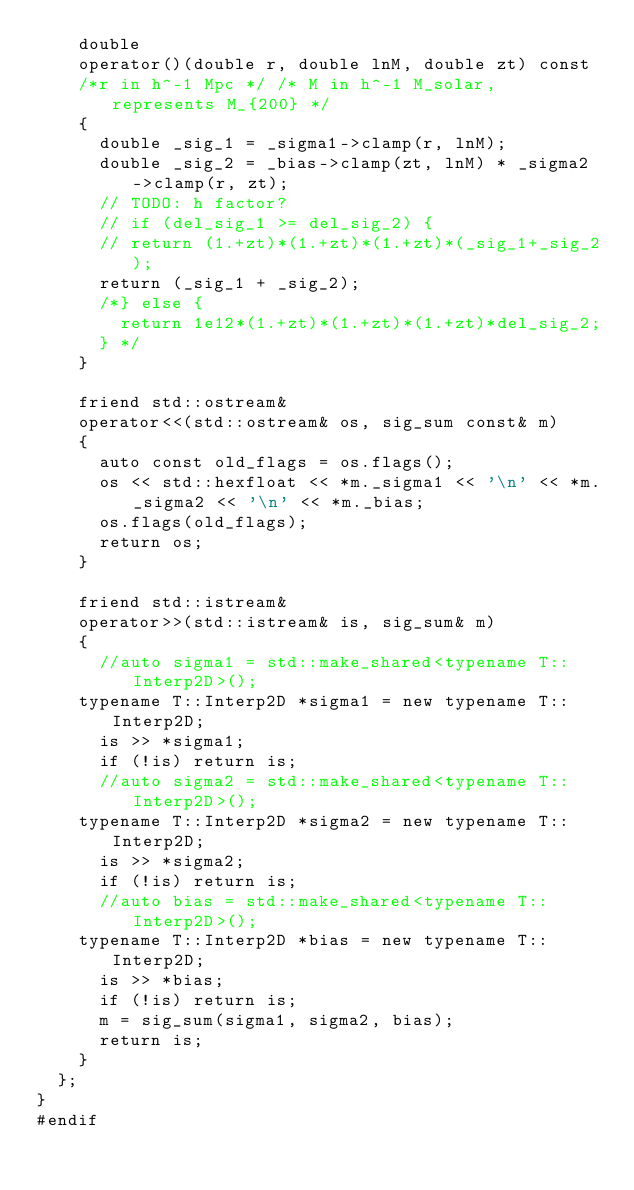Convert code to text. <code><loc_0><loc_0><loc_500><loc_500><_Cuda_>    double
    operator()(double r, double lnM, double zt) const
    /*r in h^-1 Mpc */ /* M in h^-1 M_solar, represents M_{200} */
    {
      double _sig_1 = _sigma1->clamp(r, lnM);
      double _sig_2 = _bias->clamp(zt, lnM) * _sigma2->clamp(r, zt);
      // TODO: h factor?
      // if (del_sig_1 >= del_sig_2) {
      // return (1.+zt)*(1.+zt)*(1.+zt)*(_sig_1+_sig_2);
      return (_sig_1 + _sig_2);
      /*} else {
        return 1e12*(1.+zt)*(1.+zt)*(1.+zt)*del_sig_2;
      } */
    }

    friend std::ostream&
    operator<<(std::ostream& os, sig_sum const& m)
    {
      auto const old_flags = os.flags();
      os << std::hexfloat << *m._sigma1 << '\n' << *m._sigma2 << '\n' << *m._bias;
      os.flags(old_flags);
      return os;
    }
	
    friend std::istream&
    operator>>(std::istream& is, sig_sum& m)
    {
      //auto sigma1 = std::make_shared<typename T::Interp2D>();
	  typename T::Interp2D *sigma1 = new typename T::Interp2D;
      is >> *sigma1;
      if (!is) return is;
      //auto sigma2 = std::make_shared<typename T::Interp2D>();
	  typename T::Interp2D *sigma2 = new typename T::Interp2D;
      is >> *sigma2;
      if (!is) return is;
      //auto bias = std::make_shared<typename T::Interp2D>();
	  typename T::Interp2D *bias = new typename T::Interp2D;
      is >> *bias;
      if (!is) return is;
      m = sig_sum(sigma1, sigma2, bias);
      return is;
    }
  };
}
#endif</code> 